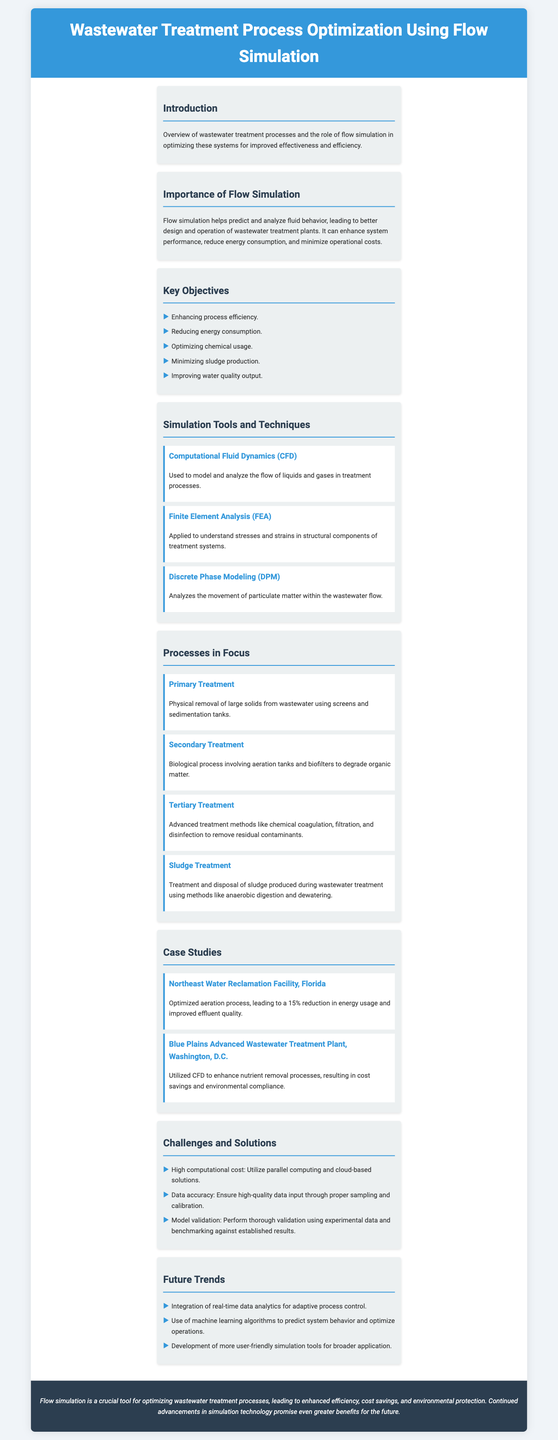what is the title of the document? The title is displayed prominently at the top of the document, highlighting the main topic of discussion.
Answer: Wastewater Treatment Process Optimization Using Flow Simulation what is one objective mentioned in the document? The document lists several objectives under the Key Objectives section, providing clear aims for process optimization.
Answer: Enhancing process efficiency which simulation tool is used to model fluid flow? The document specifies different simulation tools in the section titled Simulation Tools and Techniques, identifying their primary functions.
Answer: Computational Fluid Dynamics (CFD) how much reduction in energy usage was achieved at the Northeast Water Reclamation Facility? The case study for the Northeast Water Reclamation Facility provides specific percentage improvements realized through optimizations.
Answer: 15% what is a challenge mentioned in the Challenges and Solutions section? The Challenges and Solutions section identifies various issues faced during wastewater treatment optimization, providing actionable solutions.
Answer: High computational cost which treatment process involves biological degradation of organic matter? The Processes in Focus section outlines the specific types of treatment and their methodologies, clarifying their roles in the overall process.
Answer: Secondary Treatment what future trend involves real-time data? The Future Trends section discusses advancements expected in wastewater treatment technologies, focusing on improvements in data usage.
Answer: Integration of real-time data analytics which case study utilized CFD for nutrient removal? The document presents multiple case studies, specifying how different facilities applied flow simulation techniques to optimize performance.
Answer: Blue Plains Advanced Wastewater Treatment Plant, Washington, D.C what is the conclusion's focus? The conclusion summarizes the overall implications and future potential of flow simulation in wastewater treatment, emphasizing its benefits.
Answer: Enhanced efficiency, cost savings, and environmental protection 